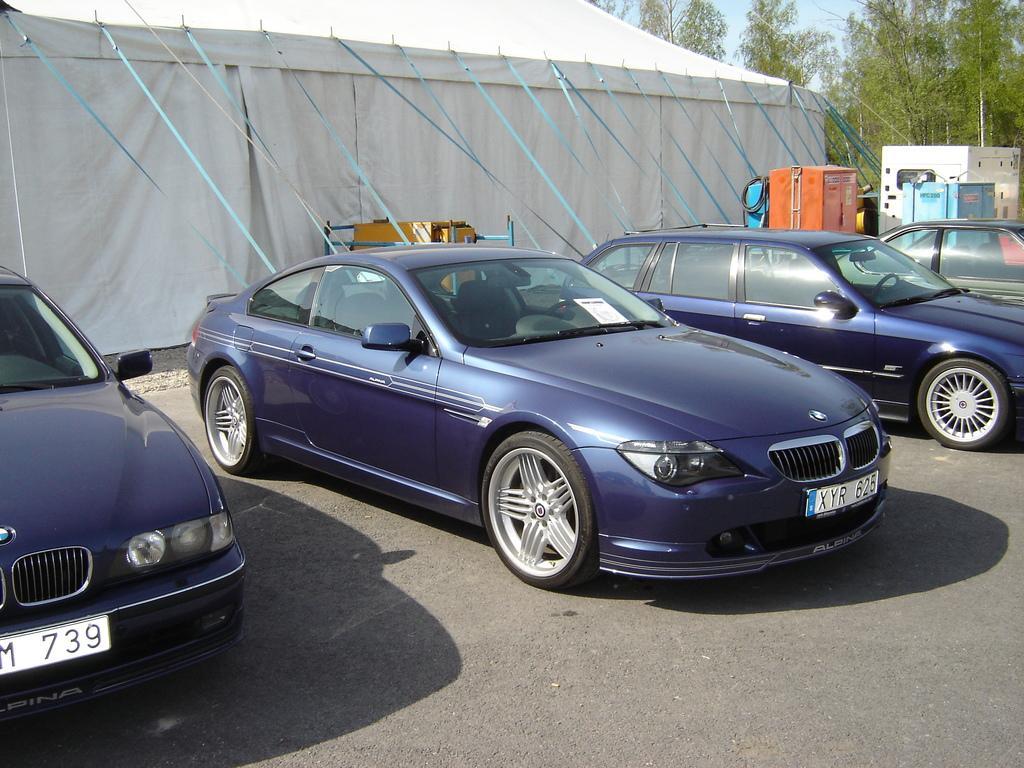Could you give a brief overview of what you see in this image? In the center of the image we can see cars on the road. In the background there is a tent, trees and a generator. 